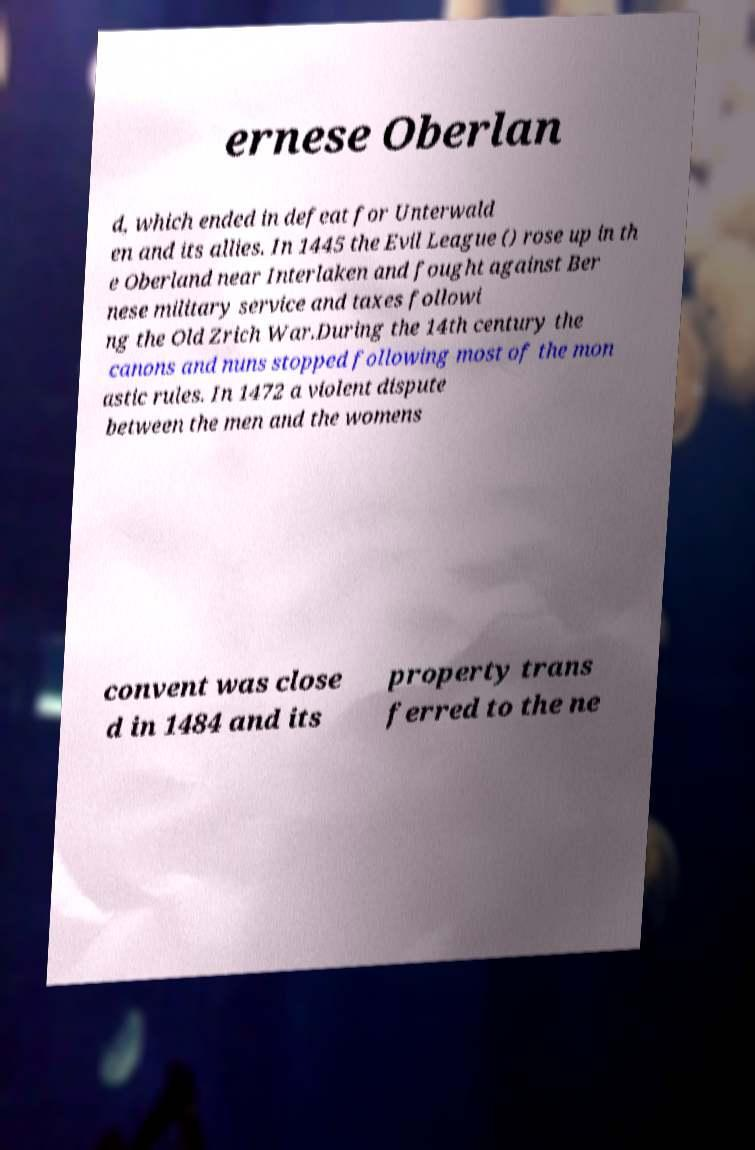Could you assist in decoding the text presented in this image and type it out clearly? ernese Oberlan d, which ended in defeat for Unterwald en and its allies. In 1445 the Evil League () rose up in th e Oberland near Interlaken and fought against Ber nese military service and taxes followi ng the Old Zrich War.During the 14th century the canons and nuns stopped following most of the mon astic rules. In 1472 a violent dispute between the men and the womens convent was close d in 1484 and its property trans ferred to the ne 